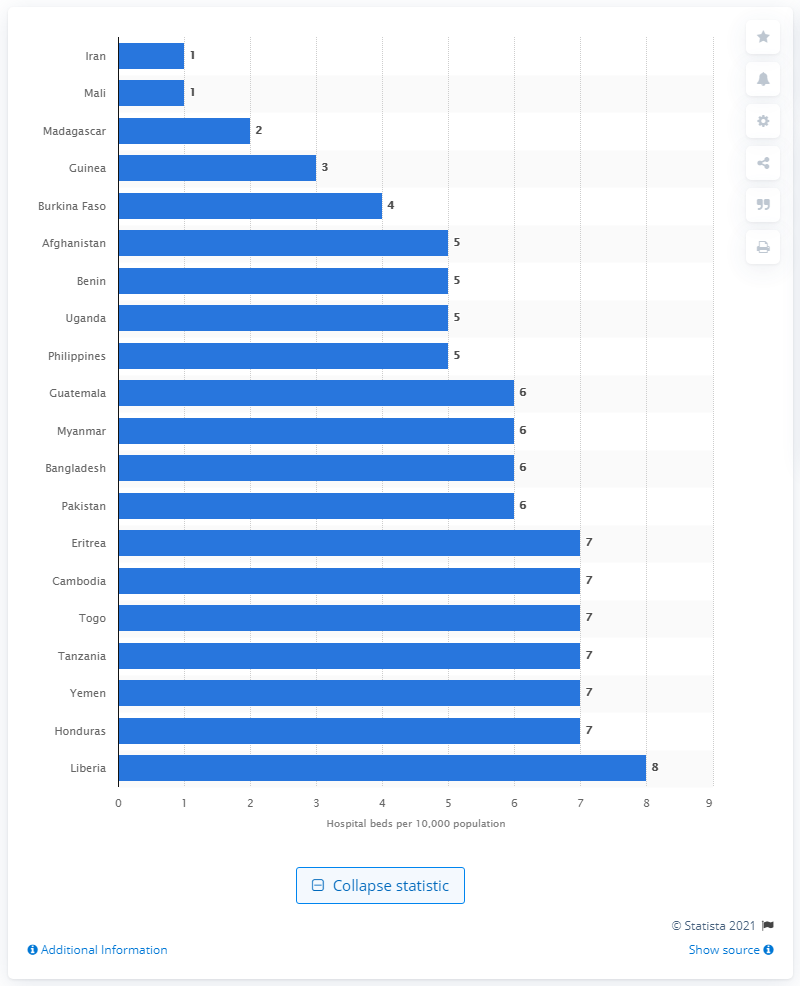Identify some key points in this picture. According to data from 2012, Mali had the lowest density of hospital beds worldwide. 